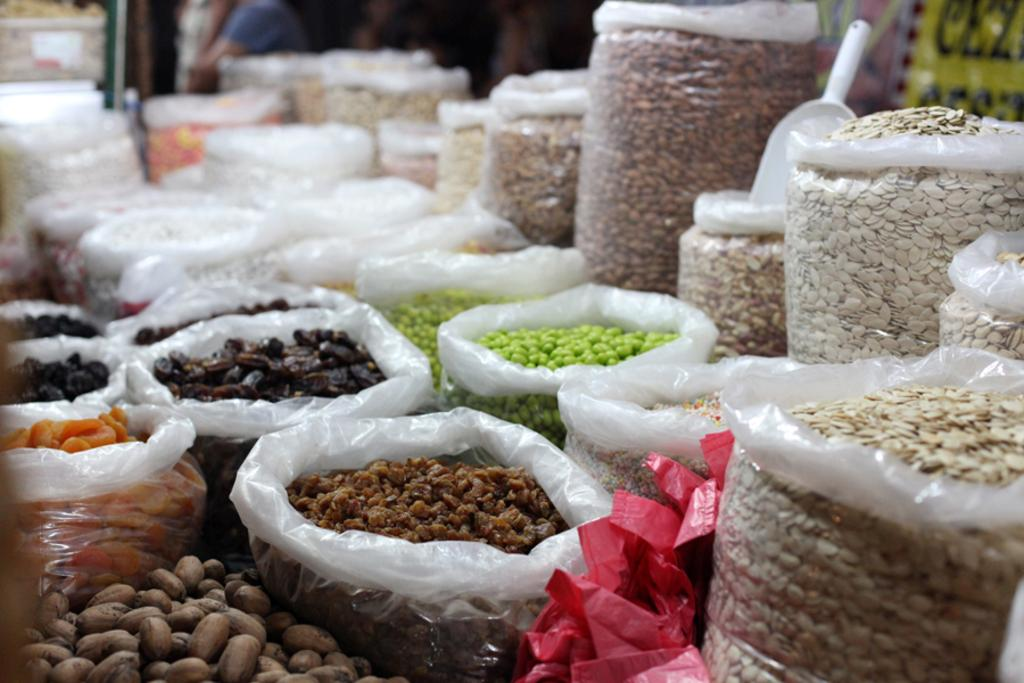What types of food items are visible in the image? The image consists of grains and nuts. How are the grains and nuts stored in the image? The grains and nuts are kept in plastic bags. Where might this image have been taken? The setting appears to be a shop. Can you identify any specific types of grains or nuts in the image? Groundnuts are located at the left bottom of the image, and dates are present in the middle of the image. What type of industry is being offered in the image? There is no industry being offered in the image; it features grains and nuts stored in plastic bags. Can you see a spoon being used to serve the grains and nuts in the image? There is no spoon visible in the image. 